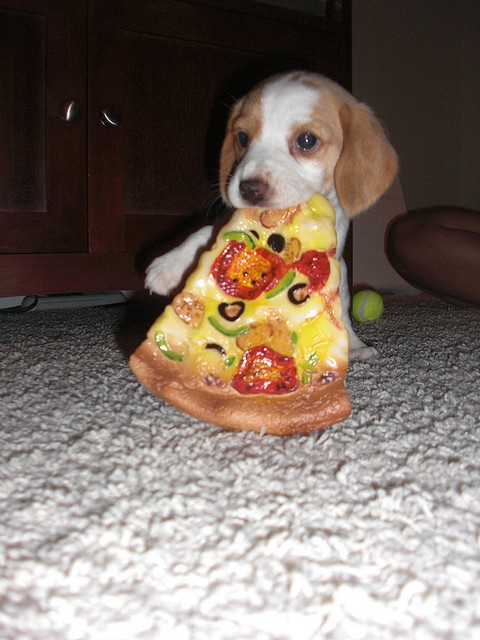Describe the objects in this image and their specific colors. I can see pizza in black, tan, khaki, salmon, and brown tones, dog in black, gray, darkgray, and lightgray tones, people in black tones, and sports ball in black, olive, and gray tones in this image. 